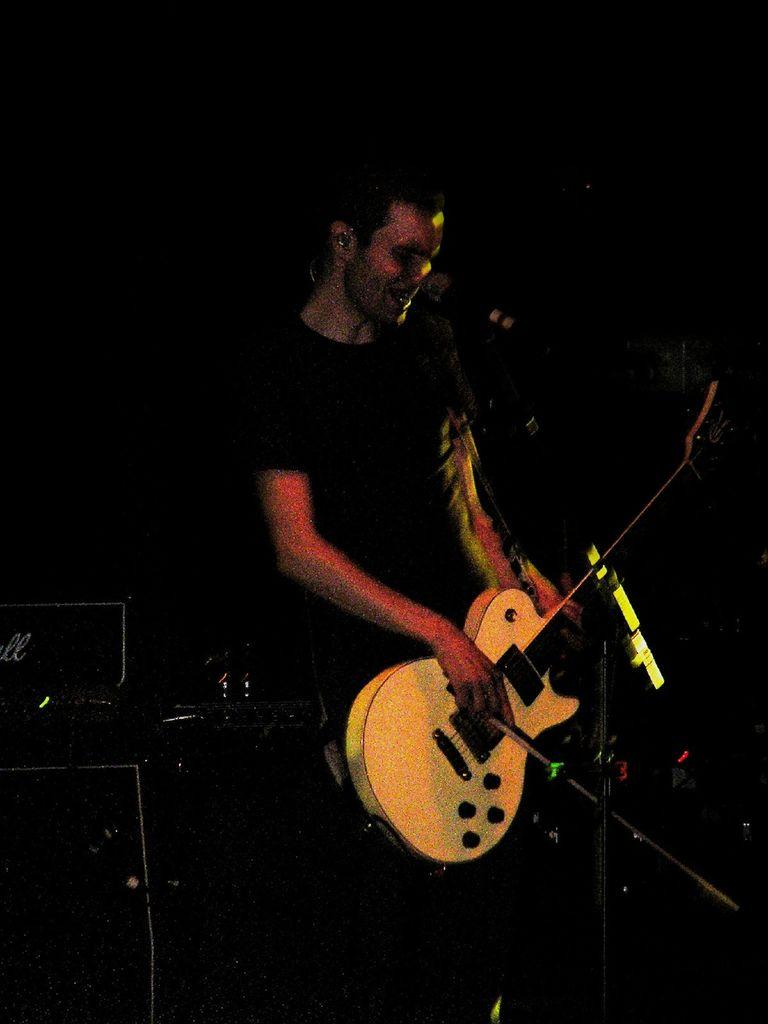What is the main subject of the image? There is a person in the image. What is the person doing in the image? The person appears to be singing and holding a guitar. Is the person actively playing the guitar in the image? No, the person is not actively playing the guitar in the image. What type of event does the scene resemble? The scene resembles a musical concert. What level of detail can be seen in the caption of the image? There is no caption present in the image, so it is not possible to determine the level of detail in a caption. 